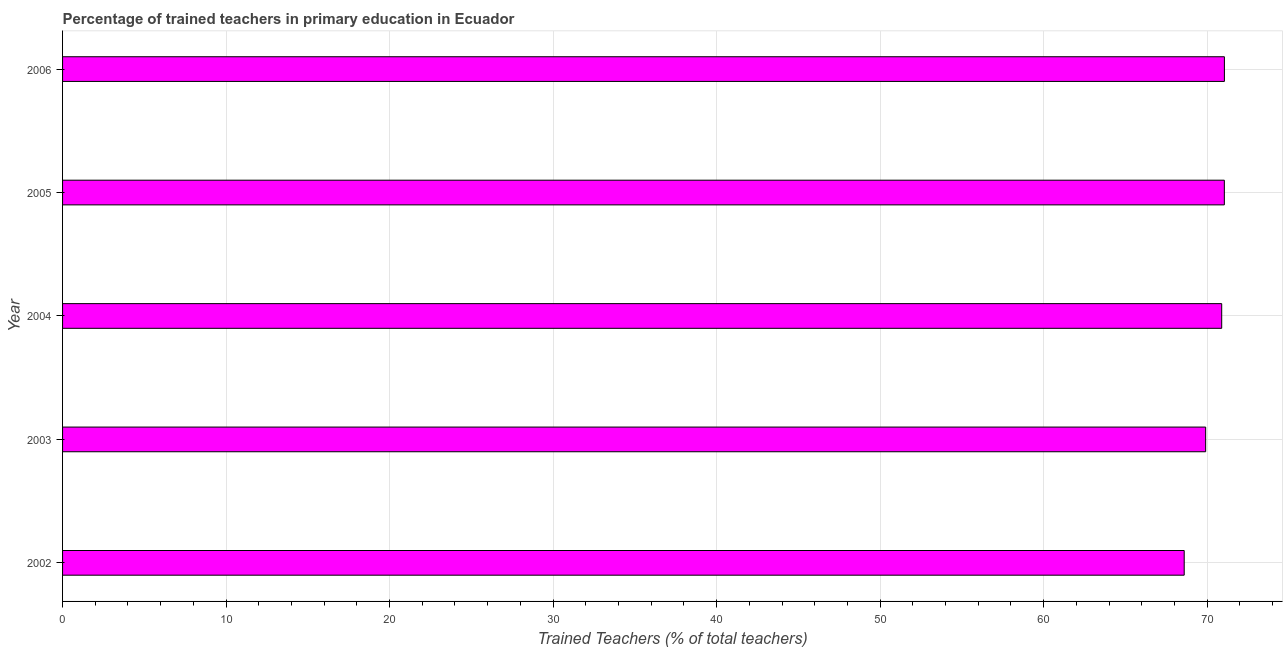Does the graph contain grids?
Offer a terse response. Yes. What is the title of the graph?
Your response must be concise. Percentage of trained teachers in primary education in Ecuador. What is the label or title of the X-axis?
Offer a very short reply. Trained Teachers (% of total teachers). What is the label or title of the Y-axis?
Your answer should be compact. Year. What is the percentage of trained teachers in 2004?
Make the answer very short. 70.89. Across all years, what is the maximum percentage of trained teachers?
Provide a short and direct response. 71.06. Across all years, what is the minimum percentage of trained teachers?
Provide a succinct answer. 68.6. In which year was the percentage of trained teachers maximum?
Give a very brief answer. 2006. In which year was the percentage of trained teachers minimum?
Your answer should be compact. 2002. What is the sum of the percentage of trained teachers?
Give a very brief answer. 351.51. What is the difference between the percentage of trained teachers in 2002 and 2006?
Provide a succinct answer. -2.46. What is the average percentage of trained teachers per year?
Ensure brevity in your answer.  70.3. What is the median percentage of trained teachers?
Offer a terse response. 70.89. Is the difference between the percentage of trained teachers in 2002 and 2003 greater than the difference between any two years?
Provide a succinct answer. No. What is the difference between the highest and the second highest percentage of trained teachers?
Make the answer very short. 0. What is the difference between the highest and the lowest percentage of trained teachers?
Your answer should be compact. 2.46. How many bars are there?
Offer a terse response. 5. Are all the bars in the graph horizontal?
Ensure brevity in your answer.  Yes. Are the values on the major ticks of X-axis written in scientific E-notation?
Your answer should be compact. No. What is the Trained Teachers (% of total teachers) in 2002?
Give a very brief answer. 68.6. What is the Trained Teachers (% of total teachers) of 2003?
Make the answer very short. 69.91. What is the Trained Teachers (% of total teachers) in 2004?
Your answer should be compact. 70.89. What is the Trained Teachers (% of total teachers) of 2005?
Your answer should be compact. 71.05. What is the Trained Teachers (% of total teachers) in 2006?
Provide a short and direct response. 71.06. What is the difference between the Trained Teachers (% of total teachers) in 2002 and 2003?
Keep it short and to the point. -1.31. What is the difference between the Trained Teachers (% of total teachers) in 2002 and 2004?
Provide a succinct answer. -2.29. What is the difference between the Trained Teachers (% of total teachers) in 2002 and 2005?
Make the answer very short. -2.46. What is the difference between the Trained Teachers (% of total teachers) in 2002 and 2006?
Your answer should be compact. -2.46. What is the difference between the Trained Teachers (% of total teachers) in 2003 and 2004?
Make the answer very short. -0.98. What is the difference between the Trained Teachers (% of total teachers) in 2003 and 2005?
Your answer should be very brief. -1.14. What is the difference between the Trained Teachers (% of total teachers) in 2003 and 2006?
Give a very brief answer. -1.15. What is the difference between the Trained Teachers (% of total teachers) in 2004 and 2005?
Ensure brevity in your answer.  -0.16. What is the difference between the Trained Teachers (% of total teachers) in 2004 and 2006?
Ensure brevity in your answer.  -0.17. What is the difference between the Trained Teachers (% of total teachers) in 2005 and 2006?
Provide a short and direct response. -0. What is the ratio of the Trained Teachers (% of total teachers) in 2002 to that in 2004?
Make the answer very short. 0.97. What is the ratio of the Trained Teachers (% of total teachers) in 2003 to that in 2006?
Provide a succinct answer. 0.98. What is the ratio of the Trained Teachers (% of total teachers) in 2004 to that in 2005?
Provide a succinct answer. 1. 